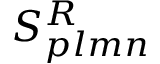Convert formula to latex. <formula><loc_0><loc_0><loc_500><loc_500>S _ { p l m n } ^ { R }</formula> 